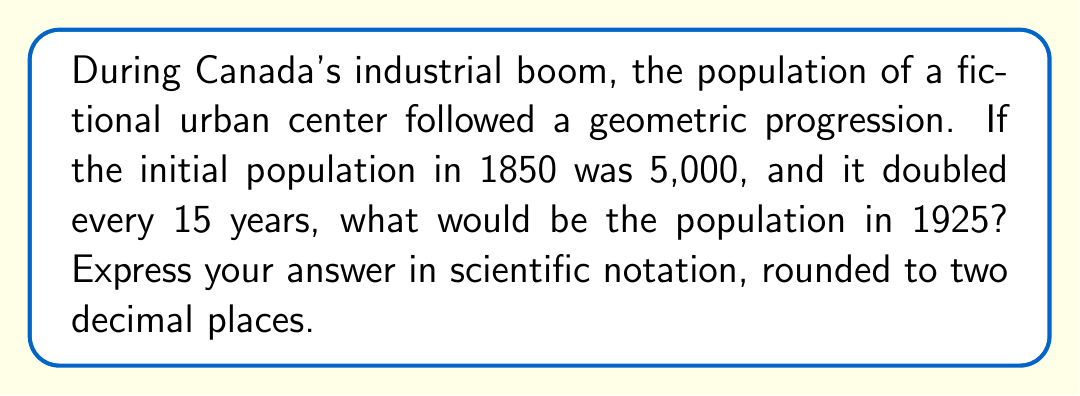Could you help me with this problem? Let's approach this step-by-step:

1) First, we need to identify the elements of our geometric progression:
   - Initial term (a): 5,000
   - Common ratio (r): 2 (population doubles every 15 years)
   - Time span: 1925 - 1850 = 75 years

2) We need to determine how many 15-year periods occurred in 75 years:
   $n = 75 \div 15 = 5$

3) The formula for the nth term of a geometric progression is:
   $a_n = a \cdot r^{n-1}$

4) Substituting our values:
   $a_5 = 5000 \cdot 2^{5-1}$
   $a_5 = 5000 \cdot 2^4$

5) Calculate:
   $a_5 = 5000 \cdot 16 = 80,000$

6) Converting to scientific notation:
   $80,000 = 8.00 \times 10^4$

Therefore, the population in 1925 would be $8.00 \times 10^4$.
Answer: $8.00 \times 10^4$ 